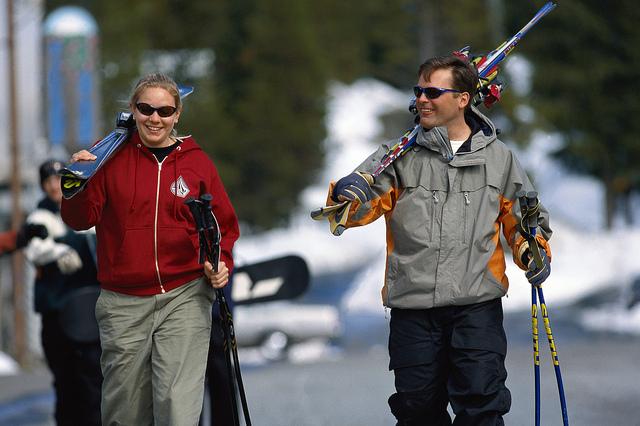Are they surfers?
Be succinct. No. Do the couple know each other?
Short answer required. Yes. Which shoulders carry ski's?
Keep it brief. Right. 